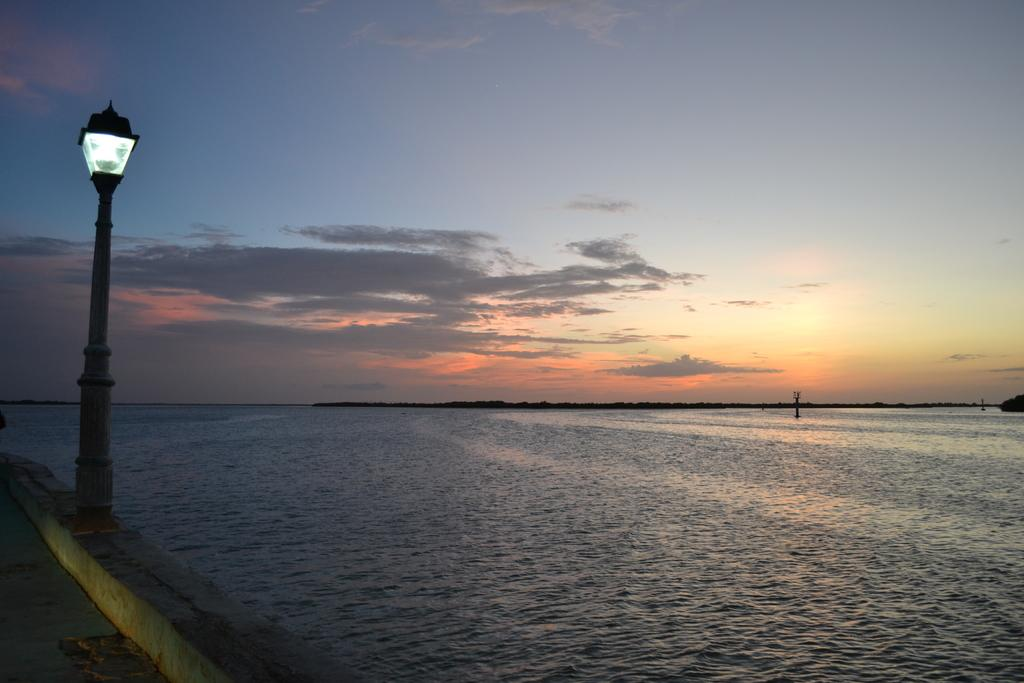What is the primary element visible in the image? There is water in the image. What structure can be seen near the water? There is a pole with a light in the image. What type of surface is present in the image? There is a road in the image. What can be seen in the sky in the background of the image? There are clouds in the sky in the background of the image. What event is taking place in the image? There is no event taking place in the image; it is a static scene featuring water, a pole with a light, a road, and clouds in the sky. 